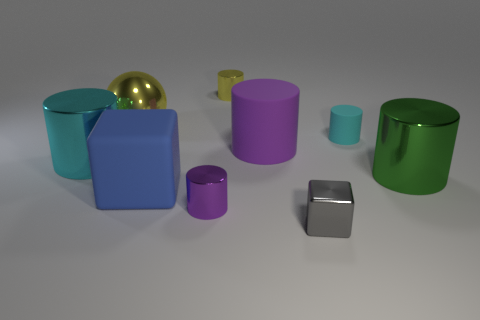Subtract all cyan shiny cylinders. How many cylinders are left? 5 Subtract all green cylinders. How many cylinders are left? 5 Subtract all yellow blocks. Subtract all green cylinders. How many blocks are left? 2 Subtract all cylinders. How many objects are left? 3 Subtract all matte objects. Subtract all big things. How many objects are left? 1 Add 2 tiny yellow metallic cylinders. How many tiny yellow metallic cylinders are left? 3 Add 9 tiny yellow metal balls. How many tiny yellow metal balls exist? 9 Subtract 1 gray cubes. How many objects are left? 8 